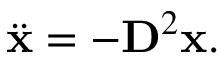Convert formula to latex. <formula><loc_0><loc_0><loc_500><loc_500>\ddot { x } = - D ^ { 2 } x .</formula> 